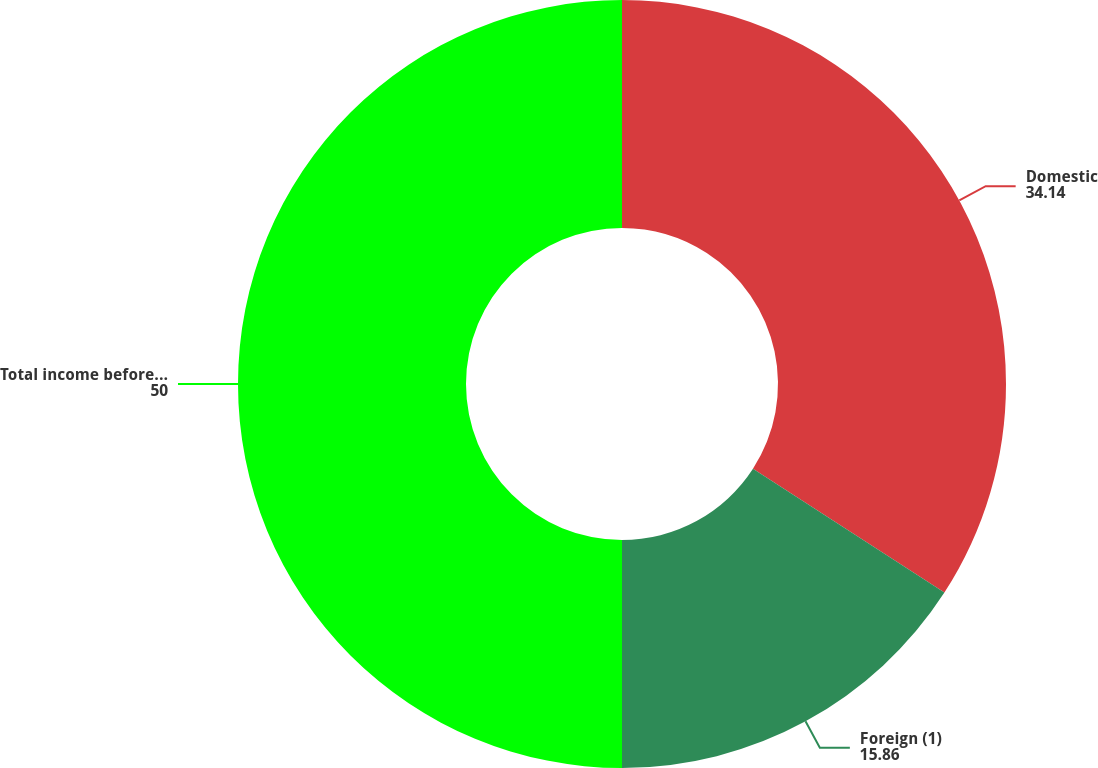<chart> <loc_0><loc_0><loc_500><loc_500><pie_chart><fcel>Domestic<fcel>Foreign (1)<fcel>Total income before provision<nl><fcel>34.14%<fcel>15.86%<fcel>50.0%<nl></chart> 